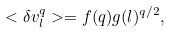<formula> <loc_0><loc_0><loc_500><loc_500>< \delta v _ { l } ^ { q } > = f ( q ) g ( l ) ^ { q / 2 } ,</formula> 